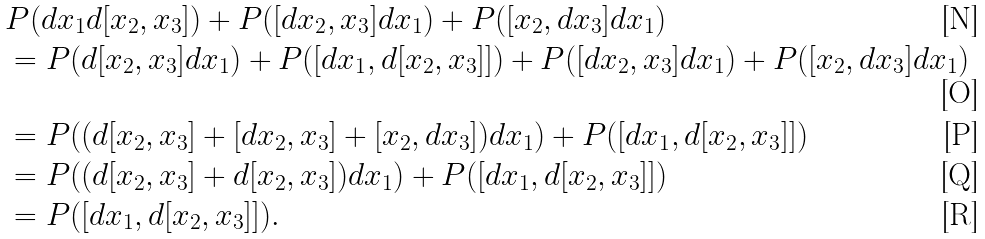<formula> <loc_0><loc_0><loc_500><loc_500>& P ( d x _ { 1 } d [ x _ { 2 } , x _ { 3 } ] ) + P ( [ d x _ { 2 } , x _ { 3 } ] d x _ { 1 } ) + P ( [ x _ { 2 } , d x _ { 3 } ] d x _ { 1 } ) \\ & = P ( d [ x _ { 2 } , x _ { 3 } ] d x _ { 1 } ) + P ( [ d x _ { 1 } , d [ x _ { 2 } , x _ { 3 } ] ] ) + P ( [ d x _ { 2 } , x _ { 3 } ] d x _ { 1 } ) + P ( [ x _ { 2 } , d x _ { 3 } ] d x _ { 1 } ) \\ & = P ( ( d [ x _ { 2 } , x _ { 3 } ] + [ d x _ { 2 } , x _ { 3 } ] + [ x _ { 2 } , d x _ { 3 } ] ) d x _ { 1 } ) + P ( [ d x _ { 1 } , d [ x _ { 2 } , x _ { 3 } ] ] ) \\ & = P ( ( d [ x _ { 2 } , x _ { 3 } ] + d [ x _ { 2 } , x _ { 3 } ] ) d x _ { 1 } ) + P ( [ d x _ { 1 } , d [ x _ { 2 } , x _ { 3 } ] ] ) \\ & = P ( [ d x _ { 1 } , d [ x _ { 2 } , x _ { 3 } ] ] ) .</formula> 